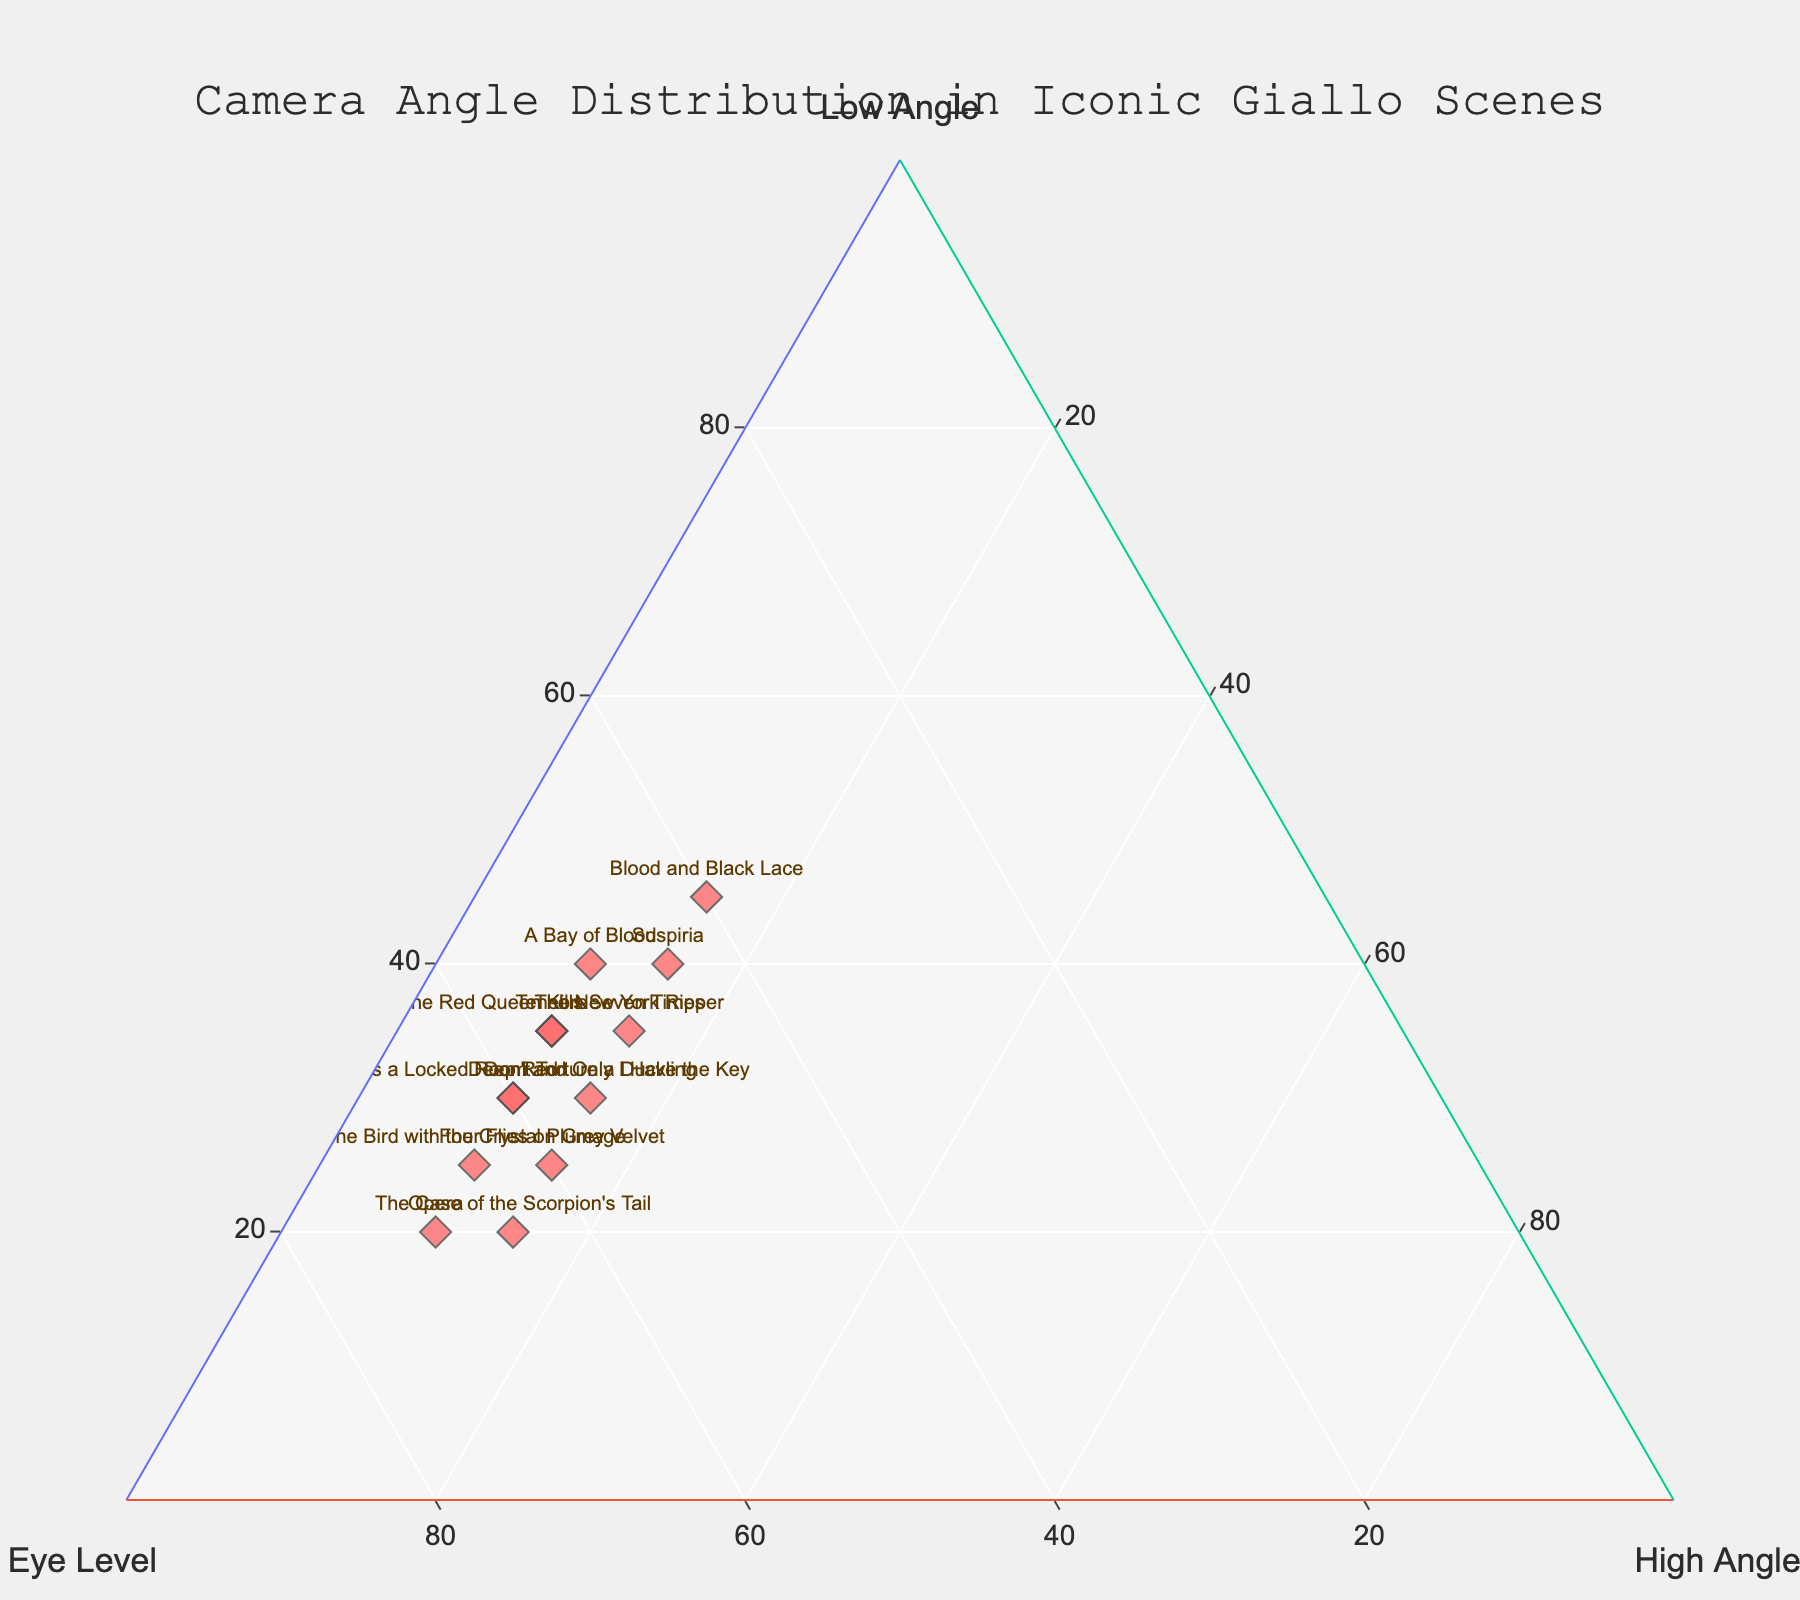What's the title of the figure? The title can be found at the top of the figure.
Answer: Camera Angle Distribution in Iconic Giallo Scenes How many films have a higher percentage of low angles than eye-level shots? By looking at the vertices closest to the "Low Angle" axis and comparing to the "Eye Level" axis, we see: Suspiria (40% > 45%), Blood and Black Lace (45% > 40%), A Bay of Blood (40% > 50%).
Answer: 3 Compare "Deep Red" and "Don't Torture a Duckling." Which film has a higher percentage of high angles? We compare the position along the "High Angle" axis: Deep Red (10%) and Don't Torture a Duckling (15%).
Answer: Don't Torture a Duckling Which film has the highest percentage of eye-level shots? By looking closest to the "Eye Level" vertex, Opera has the highest percentage with 70%.
Answer: Opera What is the approximate average percentage of low angles for all the films? Adding all low-angle percentages: (30+40+25+35+20+45+30+35+25+40+20+30+35) = 410. Dividing this sum by the number of films (13): 410/13 ≈ 31.5%.
Answer: 31.5% For "Four Flies on Grey Velvet," what is the difference between low angle and high angle percentages? From the plot, low angle is 25% and high angle is 15%. The difference is 25% - 15%.
Answer: 10% Which film has an equal percentage distribution between low angle and high angle shots? By observing the points equidistant from the "Low Angle" and "High Angle" vertices, none fit this criterion perfectly, but the closest is Suspiria with low (40%) and high (15%).
Answer: None Across all films, which camera angle type (low, eye-level, high) is most frequently adopted? The "Eye Level" angles occupy the majority in most points, indicating it is most frequently adopted.
Answer: Eye Level Compare "Tenebre" and "The Red Queen Kills Seven Times." Which film has a higher combined percentage of low and high angles? Tenebre: 35% (low) + 10% (high) = 45%, The Red Queen Kills Seven Times: 35% (low) + 10% (high) = 45%. Both have the same combined percentage.
Answer: Same Which film shows a more equal distribution among the three camera angles? By observing points central within the triangle, closest is outlier Blood and Black Lace: low (45%), eye (40%), high (15%). These percentages are closest to an equal split.
Answer: Blood and Black Lace 